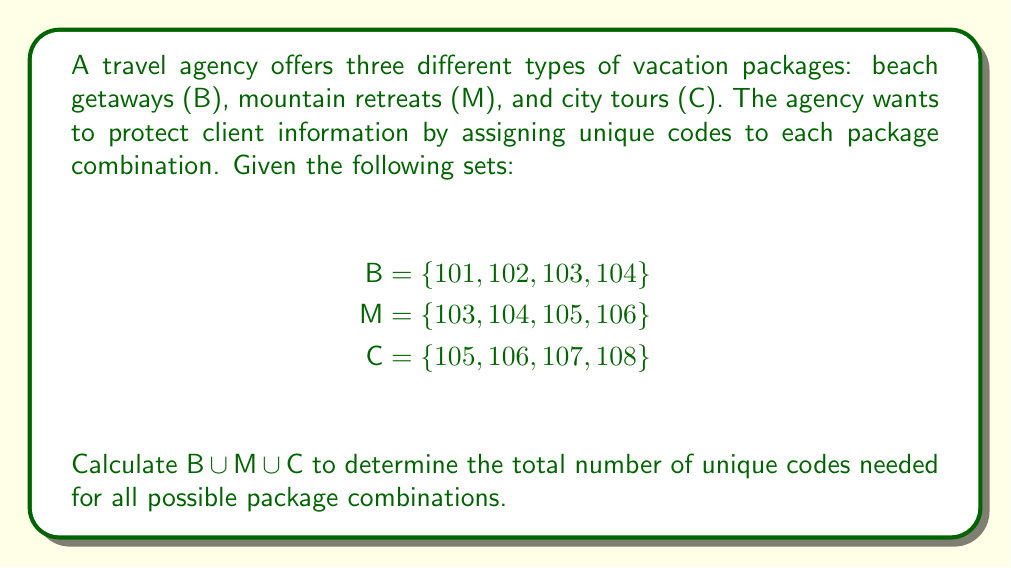Could you help me with this problem? To solve this problem, we need to find the union of the three sets B, M, and C. The union of sets includes all unique elements from all sets without repetition.

Let's approach this step-by-step:

1. First, let's list out all the elements in each set:
   B = {101, 102, 103, 104}
   M = {103, 104, 105, 106}
   C = {105, 106, 107, 108}

2. Now, we'll combine all elements, noting duplicates:
   B ∪ M ∪ C = {101, 102, 103, 104, 103, 104, 105, 106, 105, 106, 107, 108}

3. Remove duplicates to get the final union:
   B ∪ M ∪ C = {101, 102, 103, 104, 105, 106, 107, 108}

4. Count the number of elements in the final set:
   |B ∪ M ∪ C| = 8

We can also verify this result using the principle of inclusion-exclusion:

$$|B \cup M \cup C| = |B| + |M| + |C| - |B \cap M| - |B \cap C| - |M \cap C| + |B \cap M \cap C|$$

Where:
|B| = 4, |M| = 4, |C| = 4
|B ∩ M| = 2 (103, 104)
|B ∩ C| = 0
|M ∩ C| = 2 (105, 106)
|B ∩ M ∩ C| = 0

Substituting these values:

$$|B \cup M \cup C| = 4 + 4 + 4 - 2 - 0 - 2 + 0 = 8$$

This confirms our initial count.
Answer: $|B \cup M \cup C| = 8$ 